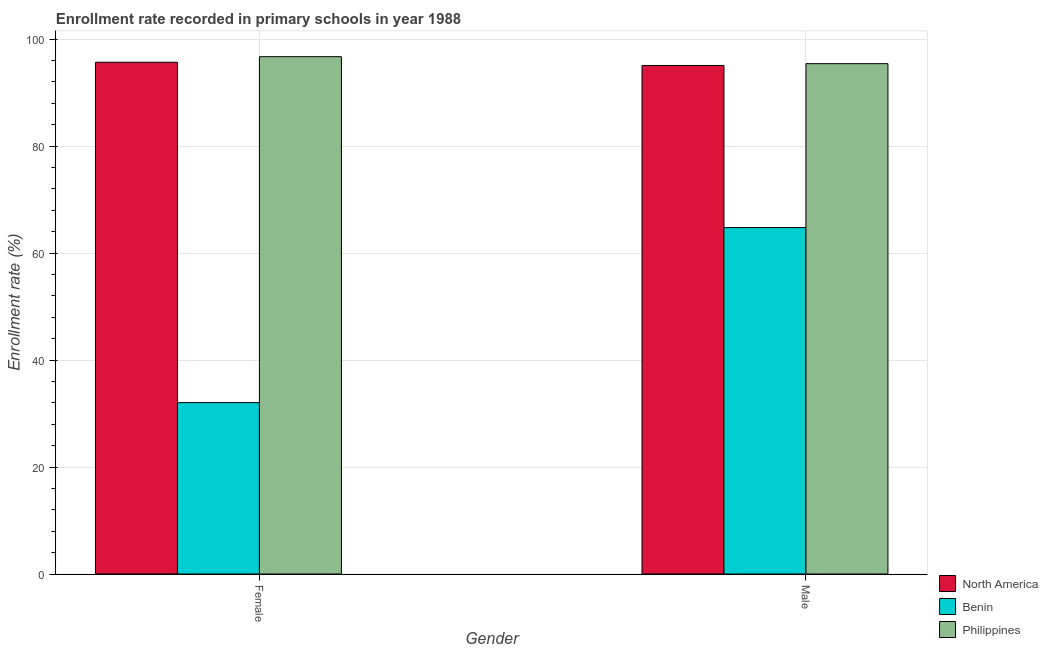How many different coloured bars are there?
Your answer should be very brief. 3. Are the number of bars per tick equal to the number of legend labels?
Keep it short and to the point. Yes. Are the number of bars on each tick of the X-axis equal?
Your response must be concise. Yes. What is the enrollment rate of male students in Benin?
Your answer should be very brief. 64.77. Across all countries, what is the maximum enrollment rate of male students?
Your answer should be very brief. 95.42. Across all countries, what is the minimum enrollment rate of female students?
Provide a short and direct response. 32.04. In which country was the enrollment rate of male students minimum?
Give a very brief answer. Benin. What is the total enrollment rate of male students in the graph?
Provide a succinct answer. 255.27. What is the difference between the enrollment rate of female students in Benin and that in North America?
Offer a terse response. -63.64. What is the difference between the enrollment rate of female students in Philippines and the enrollment rate of male students in North America?
Provide a short and direct response. 1.64. What is the average enrollment rate of male students per country?
Offer a very short reply. 85.09. What is the difference between the enrollment rate of female students and enrollment rate of male students in North America?
Give a very brief answer. 0.6. In how many countries, is the enrollment rate of male students greater than 92 %?
Your answer should be compact. 2. What is the ratio of the enrollment rate of female students in Philippines to that in North America?
Make the answer very short. 1.01. Is the enrollment rate of female students in North America less than that in Benin?
Provide a short and direct response. No. What does the 3rd bar from the right in Male represents?
Keep it short and to the point. North America. Are all the bars in the graph horizontal?
Offer a terse response. No. Are the values on the major ticks of Y-axis written in scientific E-notation?
Offer a very short reply. No. Does the graph contain any zero values?
Make the answer very short. No. How many legend labels are there?
Provide a succinct answer. 3. What is the title of the graph?
Give a very brief answer. Enrollment rate recorded in primary schools in year 1988. What is the label or title of the Y-axis?
Keep it short and to the point. Enrollment rate (%). What is the Enrollment rate (%) of North America in Female?
Your response must be concise. 95.69. What is the Enrollment rate (%) in Benin in Female?
Provide a succinct answer. 32.04. What is the Enrollment rate (%) of Philippines in Female?
Provide a short and direct response. 96.72. What is the Enrollment rate (%) of North America in Male?
Offer a terse response. 95.08. What is the Enrollment rate (%) of Benin in Male?
Give a very brief answer. 64.77. What is the Enrollment rate (%) in Philippines in Male?
Your answer should be very brief. 95.42. Across all Gender, what is the maximum Enrollment rate (%) of North America?
Give a very brief answer. 95.69. Across all Gender, what is the maximum Enrollment rate (%) in Benin?
Your answer should be compact. 64.77. Across all Gender, what is the maximum Enrollment rate (%) of Philippines?
Give a very brief answer. 96.72. Across all Gender, what is the minimum Enrollment rate (%) of North America?
Ensure brevity in your answer.  95.08. Across all Gender, what is the minimum Enrollment rate (%) in Benin?
Offer a terse response. 32.04. Across all Gender, what is the minimum Enrollment rate (%) of Philippines?
Provide a short and direct response. 95.42. What is the total Enrollment rate (%) of North America in the graph?
Your response must be concise. 190.77. What is the total Enrollment rate (%) of Benin in the graph?
Provide a succinct answer. 96.81. What is the total Enrollment rate (%) in Philippines in the graph?
Offer a terse response. 192.14. What is the difference between the Enrollment rate (%) of North America in Female and that in Male?
Provide a succinct answer. 0.6. What is the difference between the Enrollment rate (%) of Benin in Female and that in Male?
Offer a very short reply. -32.73. What is the difference between the Enrollment rate (%) of Philippines in Female and that in Male?
Keep it short and to the point. 1.3. What is the difference between the Enrollment rate (%) in North America in Female and the Enrollment rate (%) in Benin in Male?
Your response must be concise. 30.91. What is the difference between the Enrollment rate (%) in North America in Female and the Enrollment rate (%) in Philippines in Male?
Keep it short and to the point. 0.27. What is the difference between the Enrollment rate (%) in Benin in Female and the Enrollment rate (%) in Philippines in Male?
Provide a succinct answer. -63.37. What is the average Enrollment rate (%) in North America per Gender?
Ensure brevity in your answer.  95.38. What is the average Enrollment rate (%) in Benin per Gender?
Provide a succinct answer. 48.41. What is the average Enrollment rate (%) of Philippines per Gender?
Provide a succinct answer. 96.07. What is the difference between the Enrollment rate (%) in North America and Enrollment rate (%) in Benin in Female?
Your answer should be very brief. 63.64. What is the difference between the Enrollment rate (%) of North America and Enrollment rate (%) of Philippines in Female?
Make the answer very short. -1.04. What is the difference between the Enrollment rate (%) in Benin and Enrollment rate (%) in Philippines in Female?
Your response must be concise. -64.68. What is the difference between the Enrollment rate (%) of North America and Enrollment rate (%) of Benin in Male?
Keep it short and to the point. 30.31. What is the difference between the Enrollment rate (%) in North America and Enrollment rate (%) in Philippines in Male?
Give a very brief answer. -0.33. What is the difference between the Enrollment rate (%) in Benin and Enrollment rate (%) in Philippines in Male?
Keep it short and to the point. -30.65. What is the ratio of the Enrollment rate (%) in North America in Female to that in Male?
Offer a terse response. 1.01. What is the ratio of the Enrollment rate (%) of Benin in Female to that in Male?
Offer a very short reply. 0.49. What is the ratio of the Enrollment rate (%) of Philippines in Female to that in Male?
Provide a short and direct response. 1.01. What is the difference between the highest and the second highest Enrollment rate (%) in North America?
Your response must be concise. 0.6. What is the difference between the highest and the second highest Enrollment rate (%) in Benin?
Keep it short and to the point. 32.73. What is the difference between the highest and the second highest Enrollment rate (%) in Philippines?
Your answer should be compact. 1.3. What is the difference between the highest and the lowest Enrollment rate (%) in North America?
Make the answer very short. 0.6. What is the difference between the highest and the lowest Enrollment rate (%) in Benin?
Offer a terse response. 32.73. What is the difference between the highest and the lowest Enrollment rate (%) in Philippines?
Make the answer very short. 1.3. 